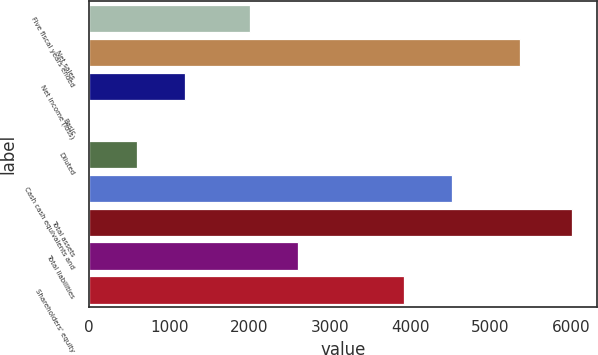Convert chart to OTSL. <chart><loc_0><loc_0><loc_500><loc_500><bar_chart><fcel>Five fiscal years ended<fcel>Net sales<fcel>Net income (loss)<fcel>Basic<fcel>Diluted<fcel>Cash cash equivalents and<fcel>Total assets<fcel>Total liabilities<fcel>Shareholders' equity<nl><fcel>2001<fcel>5363<fcel>1204.25<fcel>0.07<fcel>602.16<fcel>4522.09<fcel>6021<fcel>2603.09<fcel>3920<nl></chart> 